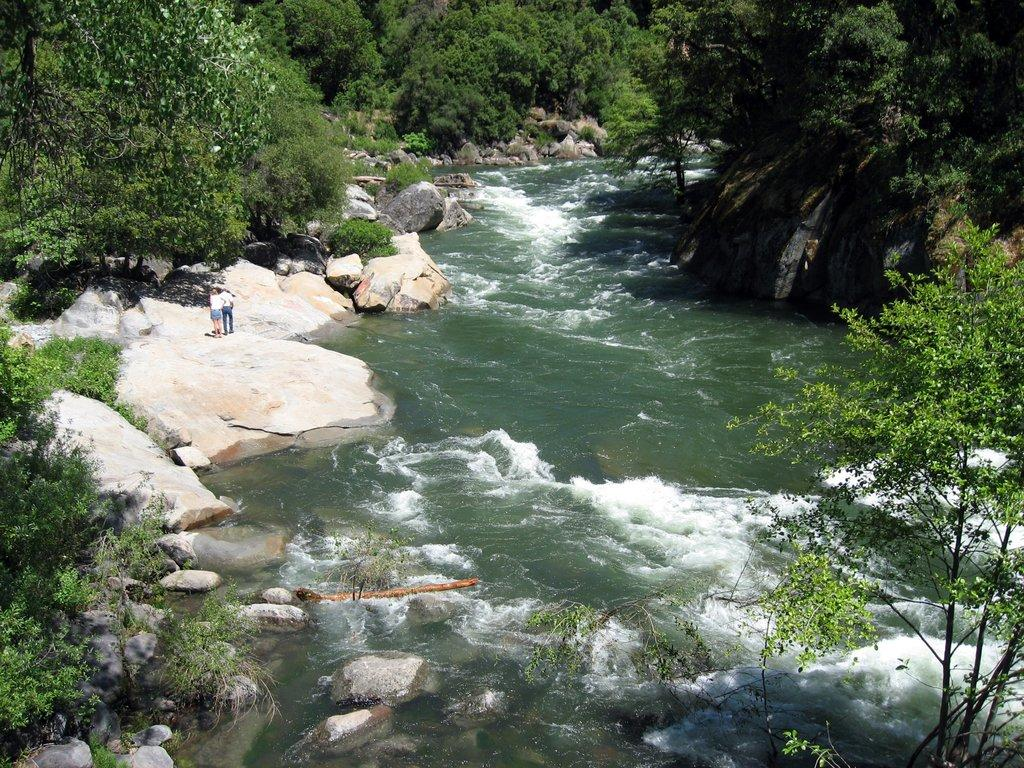What is the main feature in the center of the image? There is a canal in the center of the image. What can be seen on the left side of the image? There are two people standing on the left side of the image. What is located on the right side of the image? There is a rock on the right side of the image. What type of vegetation is visible in the background of the image? There are trees visible in the background of the image. What type of wheel is visible on the rock in the image? There is no wheel present on the rock in the image. How does the crack in the canal affect the people standing nearby? There is no crack mentioned in the canal, and therefore it does not affect the people standing nearby. 